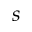<formula> <loc_0><loc_0><loc_500><loc_500>s</formula> 